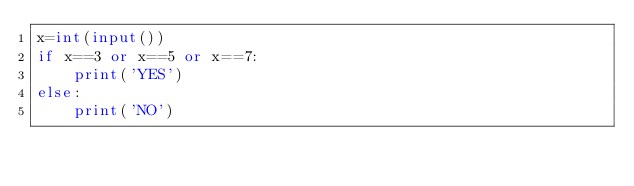<code> <loc_0><loc_0><loc_500><loc_500><_Python_>x=int(input())
if x==3 or x==5 or x==7:
    print('YES')
else:
    print('NO')</code> 